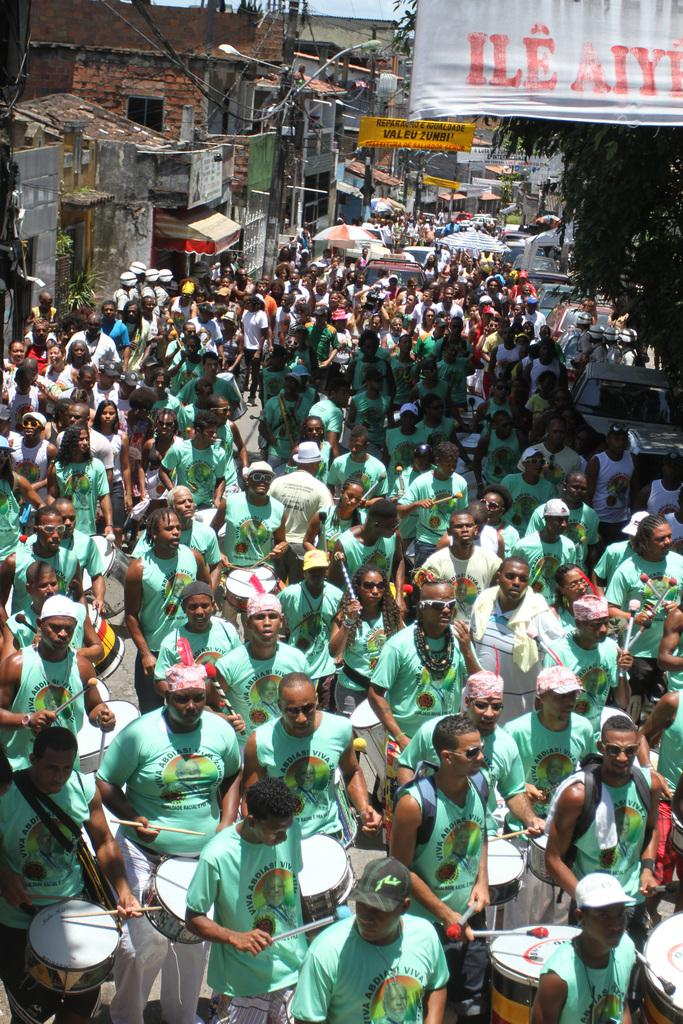How many people are the people are in the image? There is a group of people in the image. What are the people doing in the image? The people are standing and beating drums with drum sticks. What can be seen in the background of the image? There is a building, light, a pole, a banner, a tree, sky, and umbrellas visible in the background of the image. What type of seed is being used to grow the quilt in the image? There is no quilt or seed present in the image. What is the fifth element in the background of the image? The facts provided do not mention a fifth element in the background of the image. 